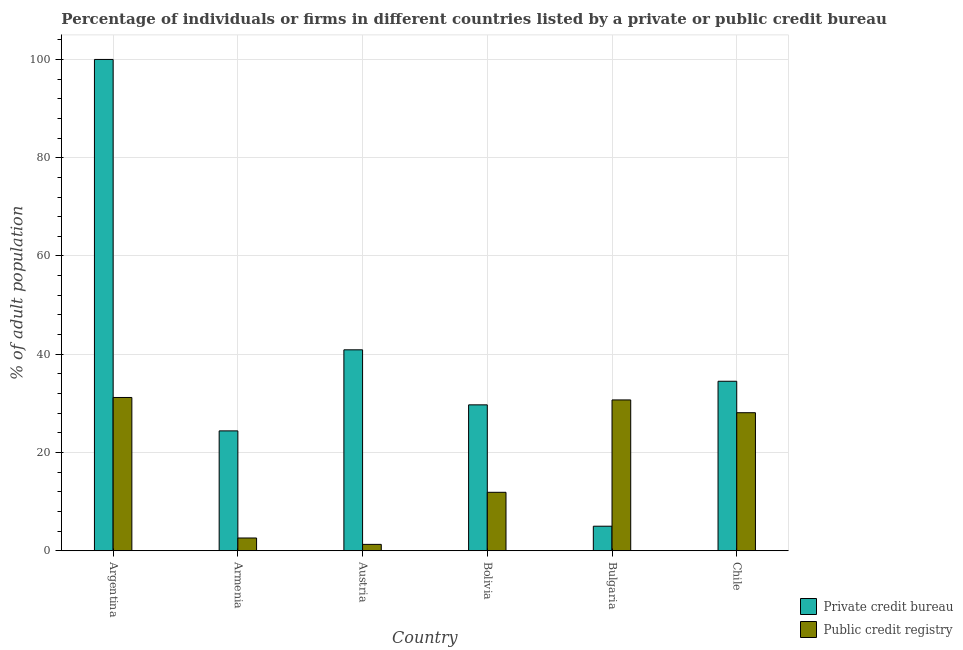How many different coloured bars are there?
Offer a terse response. 2. How many bars are there on the 4th tick from the left?
Offer a terse response. 2. How many bars are there on the 2nd tick from the right?
Provide a short and direct response. 2. What is the percentage of firms listed by public credit bureau in Bulgaria?
Ensure brevity in your answer.  30.7. In which country was the percentage of firms listed by public credit bureau maximum?
Your answer should be very brief. Argentina. In which country was the percentage of firms listed by private credit bureau minimum?
Offer a very short reply. Bulgaria. What is the total percentage of firms listed by private credit bureau in the graph?
Provide a succinct answer. 234.5. What is the difference between the percentage of firms listed by private credit bureau in Armenia and that in Bolivia?
Offer a very short reply. -5.3. What is the average percentage of firms listed by public credit bureau per country?
Ensure brevity in your answer.  17.63. What is the difference between the percentage of firms listed by private credit bureau and percentage of firms listed by public credit bureau in Chile?
Ensure brevity in your answer.  6.4. In how many countries, is the percentage of firms listed by private credit bureau greater than 80 %?
Your response must be concise. 1. What is the ratio of the percentage of firms listed by private credit bureau in Argentina to that in Chile?
Provide a short and direct response. 2.9. Is the difference between the percentage of firms listed by private credit bureau in Argentina and Armenia greater than the difference between the percentage of firms listed by public credit bureau in Argentina and Armenia?
Your answer should be compact. Yes. What does the 2nd bar from the left in Bulgaria represents?
Offer a very short reply. Public credit registry. What does the 2nd bar from the right in Chile represents?
Give a very brief answer. Private credit bureau. How many bars are there?
Provide a succinct answer. 12. Does the graph contain grids?
Make the answer very short. Yes. Where does the legend appear in the graph?
Provide a short and direct response. Bottom right. How many legend labels are there?
Your answer should be very brief. 2. What is the title of the graph?
Give a very brief answer. Percentage of individuals or firms in different countries listed by a private or public credit bureau. Does "Secondary" appear as one of the legend labels in the graph?
Offer a very short reply. No. What is the label or title of the Y-axis?
Your answer should be compact. % of adult population. What is the % of adult population of Private credit bureau in Argentina?
Ensure brevity in your answer.  100. What is the % of adult population of Public credit registry in Argentina?
Give a very brief answer. 31.2. What is the % of adult population of Private credit bureau in Armenia?
Your response must be concise. 24.4. What is the % of adult population of Private credit bureau in Austria?
Provide a succinct answer. 40.9. What is the % of adult population of Private credit bureau in Bolivia?
Give a very brief answer. 29.7. What is the % of adult population of Private credit bureau in Bulgaria?
Your response must be concise. 5. What is the % of adult population of Public credit registry in Bulgaria?
Offer a terse response. 30.7. What is the % of adult population of Private credit bureau in Chile?
Ensure brevity in your answer.  34.5. What is the % of adult population in Public credit registry in Chile?
Offer a very short reply. 28.1. Across all countries, what is the maximum % of adult population of Public credit registry?
Give a very brief answer. 31.2. Across all countries, what is the minimum % of adult population in Public credit registry?
Keep it short and to the point. 1.3. What is the total % of adult population in Private credit bureau in the graph?
Provide a short and direct response. 234.5. What is the total % of adult population in Public credit registry in the graph?
Make the answer very short. 105.8. What is the difference between the % of adult population of Private credit bureau in Argentina and that in Armenia?
Offer a terse response. 75.6. What is the difference between the % of adult population of Public credit registry in Argentina and that in Armenia?
Keep it short and to the point. 28.6. What is the difference between the % of adult population of Private credit bureau in Argentina and that in Austria?
Give a very brief answer. 59.1. What is the difference between the % of adult population in Public credit registry in Argentina and that in Austria?
Your response must be concise. 29.9. What is the difference between the % of adult population in Private credit bureau in Argentina and that in Bolivia?
Your answer should be compact. 70.3. What is the difference between the % of adult population in Public credit registry in Argentina and that in Bolivia?
Ensure brevity in your answer.  19.3. What is the difference between the % of adult population of Private credit bureau in Argentina and that in Bulgaria?
Make the answer very short. 95. What is the difference between the % of adult population of Public credit registry in Argentina and that in Bulgaria?
Your response must be concise. 0.5. What is the difference between the % of adult population in Private credit bureau in Argentina and that in Chile?
Provide a succinct answer. 65.5. What is the difference between the % of adult population in Public credit registry in Argentina and that in Chile?
Provide a succinct answer. 3.1. What is the difference between the % of adult population in Private credit bureau in Armenia and that in Austria?
Provide a short and direct response. -16.5. What is the difference between the % of adult population of Public credit registry in Armenia and that in Bolivia?
Offer a very short reply. -9.3. What is the difference between the % of adult population of Private credit bureau in Armenia and that in Bulgaria?
Give a very brief answer. 19.4. What is the difference between the % of adult population in Public credit registry in Armenia and that in Bulgaria?
Provide a succinct answer. -28.1. What is the difference between the % of adult population in Public credit registry in Armenia and that in Chile?
Make the answer very short. -25.5. What is the difference between the % of adult population in Private credit bureau in Austria and that in Bolivia?
Give a very brief answer. 11.2. What is the difference between the % of adult population of Private credit bureau in Austria and that in Bulgaria?
Give a very brief answer. 35.9. What is the difference between the % of adult population of Public credit registry in Austria and that in Bulgaria?
Ensure brevity in your answer.  -29.4. What is the difference between the % of adult population in Public credit registry in Austria and that in Chile?
Keep it short and to the point. -26.8. What is the difference between the % of adult population of Private credit bureau in Bolivia and that in Bulgaria?
Keep it short and to the point. 24.7. What is the difference between the % of adult population of Public credit registry in Bolivia and that in Bulgaria?
Your answer should be compact. -18.8. What is the difference between the % of adult population of Public credit registry in Bolivia and that in Chile?
Your answer should be compact. -16.2. What is the difference between the % of adult population of Private credit bureau in Bulgaria and that in Chile?
Keep it short and to the point. -29.5. What is the difference between the % of adult population of Private credit bureau in Argentina and the % of adult population of Public credit registry in Armenia?
Make the answer very short. 97.4. What is the difference between the % of adult population in Private credit bureau in Argentina and the % of adult population in Public credit registry in Austria?
Offer a terse response. 98.7. What is the difference between the % of adult population of Private credit bureau in Argentina and the % of adult population of Public credit registry in Bolivia?
Offer a terse response. 88.1. What is the difference between the % of adult population in Private credit bureau in Argentina and the % of adult population in Public credit registry in Bulgaria?
Provide a short and direct response. 69.3. What is the difference between the % of adult population in Private credit bureau in Argentina and the % of adult population in Public credit registry in Chile?
Your response must be concise. 71.9. What is the difference between the % of adult population in Private credit bureau in Armenia and the % of adult population in Public credit registry in Austria?
Offer a very short reply. 23.1. What is the difference between the % of adult population of Private credit bureau in Austria and the % of adult population of Public credit registry in Bulgaria?
Ensure brevity in your answer.  10.2. What is the difference between the % of adult population of Private credit bureau in Austria and the % of adult population of Public credit registry in Chile?
Your answer should be very brief. 12.8. What is the difference between the % of adult population in Private credit bureau in Bulgaria and the % of adult population in Public credit registry in Chile?
Your response must be concise. -23.1. What is the average % of adult population of Private credit bureau per country?
Provide a short and direct response. 39.08. What is the average % of adult population of Public credit registry per country?
Your response must be concise. 17.63. What is the difference between the % of adult population of Private credit bureau and % of adult population of Public credit registry in Argentina?
Give a very brief answer. 68.8. What is the difference between the % of adult population in Private credit bureau and % of adult population in Public credit registry in Armenia?
Provide a short and direct response. 21.8. What is the difference between the % of adult population of Private credit bureau and % of adult population of Public credit registry in Austria?
Your response must be concise. 39.6. What is the difference between the % of adult population in Private credit bureau and % of adult population in Public credit registry in Bolivia?
Make the answer very short. 17.8. What is the difference between the % of adult population of Private credit bureau and % of adult population of Public credit registry in Bulgaria?
Offer a terse response. -25.7. What is the difference between the % of adult population of Private credit bureau and % of adult population of Public credit registry in Chile?
Make the answer very short. 6.4. What is the ratio of the % of adult population in Private credit bureau in Argentina to that in Armenia?
Provide a succinct answer. 4.1. What is the ratio of the % of adult population of Private credit bureau in Argentina to that in Austria?
Offer a terse response. 2.44. What is the ratio of the % of adult population of Private credit bureau in Argentina to that in Bolivia?
Give a very brief answer. 3.37. What is the ratio of the % of adult population of Public credit registry in Argentina to that in Bolivia?
Keep it short and to the point. 2.62. What is the ratio of the % of adult population in Public credit registry in Argentina to that in Bulgaria?
Make the answer very short. 1.02. What is the ratio of the % of adult population in Private credit bureau in Argentina to that in Chile?
Your response must be concise. 2.9. What is the ratio of the % of adult population of Public credit registry in Argentina to that in Chile?
Your answer should be very brief. 1.11. What is the ratio of the % of adult population in Private credit bureau in Armenia to that in Austria?
Make the answer very short. 0.6. What is the ratio of the % of adult population in Public credit registry in Armenia to that in Austria?
Your answer should be very brief. 2. What is the ratio of the % of adult population of Private credit bureau in Armenia to that in Bolivia?
Make the answer very short. 0.82. What is the ratio of the % of adult population in Public credit registry in Armenia to that in Bolivia?
Offer a very short reply. 0.22. What is the ratio of the % of adult population in Private credit bureau in Armenia to that in Bulgaria?
Offer a very short reply. 4.88. What is the ratio of the % of adult population in Public credit registry in Armenia to that in Bulgaria?
Your answer should be compact. 0.08. What is the ratio of the % of adult population of Private credit bureau in Armenia to that in Chile?
Give a very brief answer. 0.71. What is the ratio of the % of adult population in Public credit registry in Armenia to that in Chile?
Make the answer very short. 0.09. What is the ratio of the % of adult population in Private credit bureau in Austria to that in Bolivia?
Your answer should be very brief. 1.38. What is the ratio of the % of adult population in Public credit registry in Austria to that in Bolivia?
Provide a short and direct response. 0.11. What is the ratio of the % of adult population in Private credit bureau in Austria to that in Bulgaria?
Your answer should be compact. 8.18. What is the ratio of the % of adult population of Public credit registry in Austria to that in Bulgaria?
Make the answer very short. 0.04. What is the ratio of the % of adult population in Private credit bureau in Austria to that in Chile?
Give a very brief answer. 1.19. What is the ratio of the % of adult population in Public credit registry in Austria to that in Chile?
Make the answer very short. 0.05. What is the ratio of the % of adult population of Private credit bureau in Bolivia to that in Bulgaria?
Keep it short and to the point. 5.94. What is the ratio of the % of adult population in Public credit registry in Bolivia to that in Bulgaria?
Make the answer very short. 0.39. What is the ratio of the % of adult population in Private credit bureau in Bolivia to that in Chile?
Your response must be concise. 0.86. What is the ratio of the % of adult population in Public credit registry in Bolivia to that in Chile?
Your response must be concise. 0.42. What is the ratio of the % of adult population of Private credit bureau in Bulgaria to that in Chile?
Your answer should be very brief. 0.14. What is the ratio of the % of adult population in Public credit registry in Bulgaria to that in Chile?
Keep it short and to the point. 1.09. What is the difference between the highest and the second highest % of adult population in Private credit bureau?
Provide a succinct answer. 59.1. What is the difference between the highest and the lowest % of adult population in Private credit bureau?
Your answer should be very brief. 95. What is the difference between the highest and the lowest % of adult population in Public credit registry?
Ensure brevity in your answer.  29.9. 